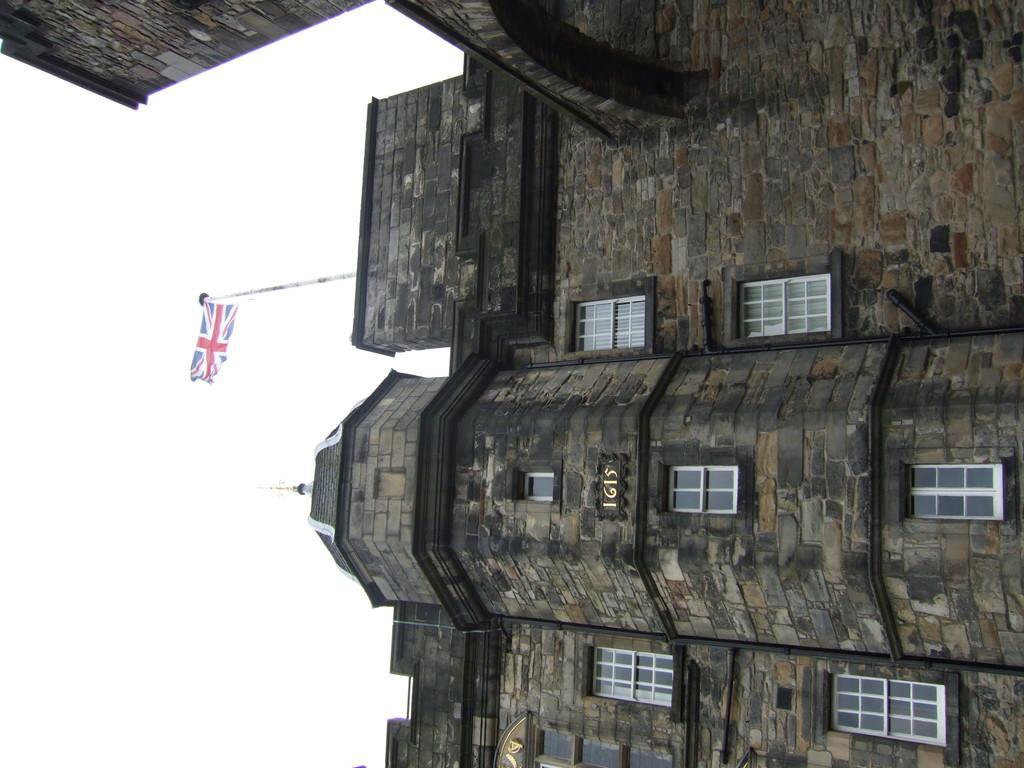How would you summarize this image in a sentence or two? This picture is taken from outside of the building. In this image, in the middle, we can see a flag. On the right side, we can see a building, glass window and a text written on the building. On the left side, we can see white color. 